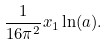<formula> <loc_0><loc_0><loc_500><loc_500>\frac { 1 } { 1 6 \pi ^ { 2 } } x _ { 1 } \ln ( a ) .</formula> 